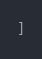<code> <loc_0><loc_0><loc_500><loc_500><_JavaScript_>]
</code> 